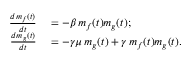<formula> <loc_0><loc_0><loc_500><loc_500>\begin{array} { r l } { \frac { d m _ { f } ( t ) } { d t } } & = - \beta \, m _ { f } ( t ) m _ { g } ( t ) ; } \\ { \frac { d m _ { g } ( t ) } { d t } } & = - \gamma \mu \, m _ { g } ( t ) + \gamma \, m _ { f } ( t ) m _ { g } ( t ) . } \end{array}</formula> 